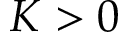Convert formula to latex. <formula><loc_0><loc_0><loc_500><loc_500>K > 0</formula> 